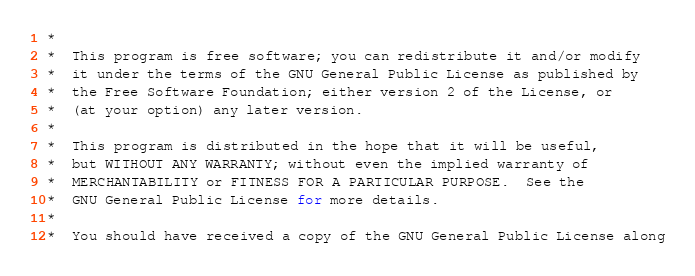Convert code to text. <code><loc_0><loc_0><loc_500><loc_500><_C_> *
 *  This program is free software; you can redistribute it and/or modify
 *  it under the terms of the GNU General Public License as published by
 *  the Free Software Foundation; either version 2 of the License, or
 *  (at your option) any later version.
 *
 *  This program is distributed in the hope that it will be useful,
 *  but WITHOUT ANY WARRANTY; without even the implied warranty of
 *  MERCHANTABILITY or FITNESS FOR A PARTICULAR PURPOSE.  See the
 *  GNU General Public License for more details.
 *
 *  You should have received a copy of the GNU General Public License along</code> 